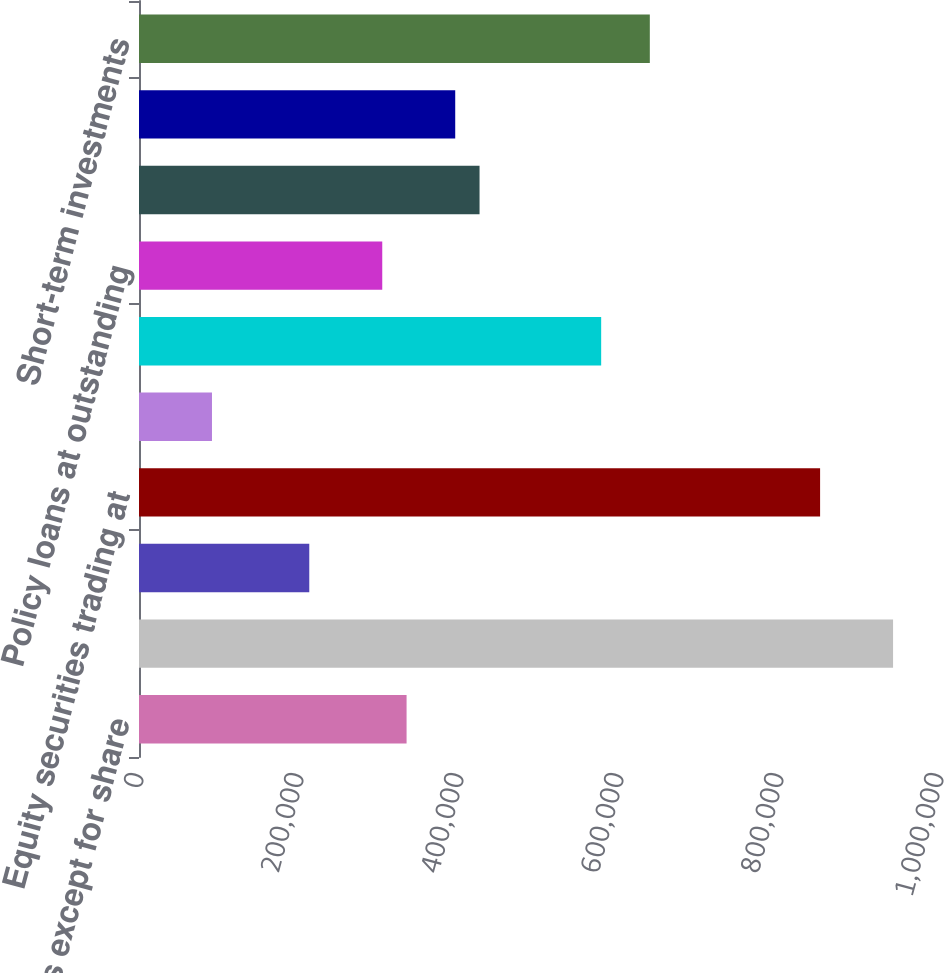Convert chart to OTSL. <chart><loc_0><loc_0><loc_500><loc_500><bar_chart><fcel>(In millions except for share<fcel>Fixed maturities<fcel>Fixed maturities at fair value<fcel>Equity securities trading at<fcel>Equity securities<fcel>Mortgage loans (net of<fcel>Policy loans at outstanding<fcel>Limited partnerships and other<fcel>Other investments<fcel>Short-term investments<nl><fcel>334470<fcel>942588<fcel>212846<fcel>851370<fcel>91222.7<fcel>577717<fcel>304064<fcel>425688<fcel>395282<fcel>638529<nl></chart> 